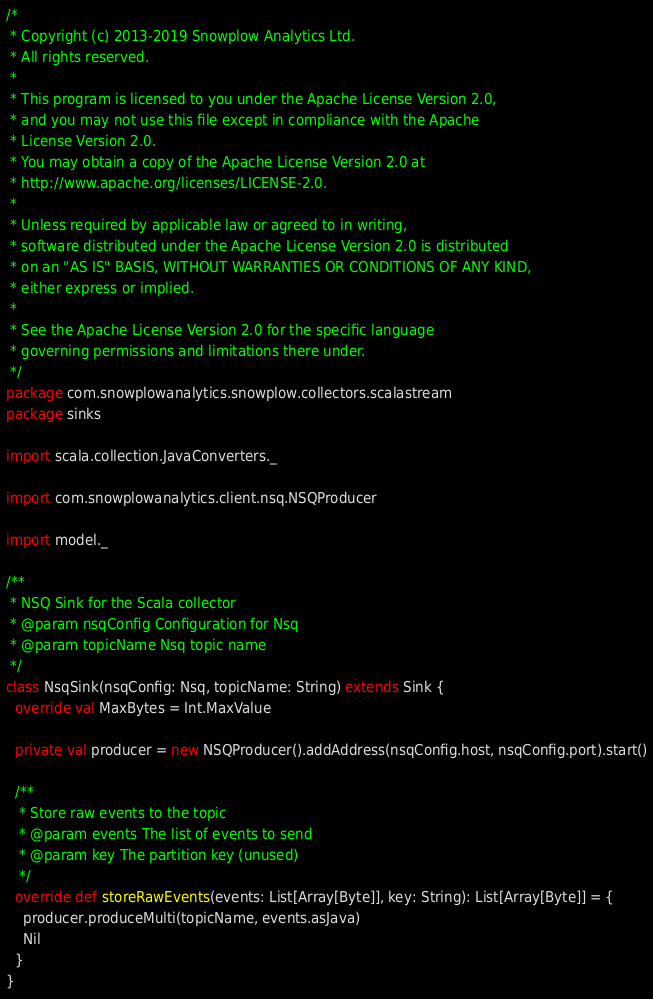<code> <loc_0><loc_0><loc_500><loc_500><_Scala_>/*
 * Copyright (c) 2013-2019 Snowplow Analytics Ltd.
 * All rights reserved.
 *
 * This program is licensed to you under the Apache License Version 2.0,
 * and you may not use this file except in compliance with the Apache
 * License Version 2.0.
 * You may obtain a copy of the Apache License Version 2.0 at
 * http://www.apache.org/licenses/LICENSE-2.0.
 *
 * Unless required by applicable law or agreed to in writing,
 * software distributed under the Apache License Version 2.0 is distributed
 * on an "AS IS" BASIS, WITHOUT WARRANTIES OR CONDITIONS OF ANY KIND,
 * either express or implied.
 *
 * See the Apache License Version 2.0 for the specific language
 * governing permissions and limitations there under.
 */
package com.snowplowanalytics.snowplow.collectors.scalastream
package sinks

import scala.collection.JavaConverters._

import com.snowplowanalytics.client.nsq.NSQProducer

import model._

/**
 * NSQ Sink for the Scala collector
 * @param nsqConfig Configuration for Nsq
 * @param topicName Nsq topic name
 */
class NsqSink(nsqConfig: Nsq, topicName: String) extends Sink {
  override val MaxBytes = Int.MaxValue

  private val producer = new NSQProducer().addAddress(nsqConfig.host, nsqConfig.port).start()

  /**
   * Store raw events to the topic
   * @param events The list of events to send
   * @param key The partition key (unused)
   */
  override def storeRawEvents(events: List[Array[Byte]], key: String): List[Array[Byte]] = {
    producer.produceMulti(topicName, events.asJava)
    Nil
  }
}
</code> 